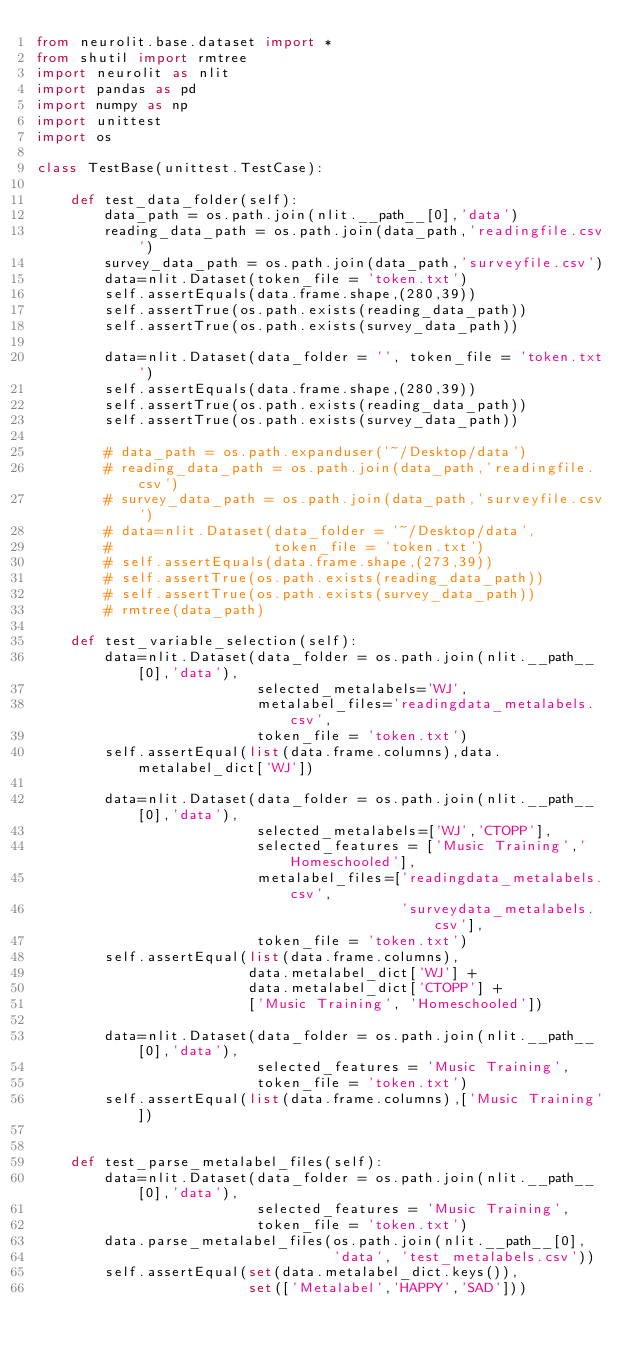<code> <loc_0><loc_0><loc_500><loc_500><_Python_>from neurolit.base.dataset import *
from shutil import rmtree
import neurolit as nlit
import pandas as pd
import numpy as np
import unittest
import os

class TestBase(unittest.TestCase):

    def test_data_folder(self):
        data_path = os.path.join(nlit.__path__[0],'data')
        reading_data_path = os.path.join(data_path,'readingfile.csv')
        survey_data_path = os.path.join(data_path,'surveyfile.csv')
        data=nlit.Dataset(token_file = 'token.txt')
        self.assertEquals(data.frame.shape,(280,39))
        self.assertTrue(os.path.exists(reading_data_path))
        self.assertTrue(os.path.exists(survey_data_path))

        data=nlit.Dataset(data_folder = '', token_file = 'token.txt')
        self.assertEquals(data.frame.shape,(280,39))
        self.assertTrue(os.path.exists(reading_data_path))
        self.assertTrue(os.path.exists(survey_data_path))

        # data_path = os.path.expanduser('~/Desktop/data')
        # reading_data_path = os.path.join(data_path,'readingfile.csv')
        # survey_data_path = os.path.join(data_path,'surveyfile.csv')
        # data=nlit.Dataset(data_folder = '~/Desktop/data',
        #                   token_file = 'token.txt')
        # self.assertEquals(data.frame.shape,(273,39))
        # self.assertTrue(os.path.exists(reading_data_path))
        # self.assertTrue(os.path.exists(survey_data_path))
        # rmtree(data_path)

    def test_variable_selection(self):
        data=nlit.Dataset(data_folder = os.path.join(nlit.__path__[0],'data'),
                          selected_metalabels='WJ',
                          metalabel_files='readingdata_metalabels.csv',
                          token_file = 'token.txt')
        self.assertEqual(list(data.frame.columns),data.metalabel_dict['WJ'])

        data=nlit.Dataset(data_folder = os.path.join(nlit.__path__[0],'data'),
                          selected_metalabels=['WJ','CTOPP'],
                          selected_features = ['Music Training','Homeschooled'],
                          metalabel_files=['readingdata_metalabels.csv',
                                           'surveydata_metalabels.csv'],
                          token_file = 'token.txt')
        self.assertEqual(list(data.frame.columns),
                         data.metalabel_dict['WJ'] +
                         data.metalabel_dict['CTOPP'] +
                         ['Music Training', 'Homeschooled'])

        data=nlit.Dataset(data_folder = os.path.join(nlit.__path__[0],'data'),
                          selected_features = 'Music Training',
                          token_file = 'token.txt')
        self.assertEqual(list(data.frame.columns),['Music Training'])


    def test_parse_metalabel_files(self):
        data=nlit.Dataset(data_folder = os.path.join(nlit.__path__[0],'data'),
                          selected_features = 'Music Training',
                          token_file = 'token.txt')
        data.parse_metalabel_files(os.path.join(nlit.__path__[0],
                                   'data', 'test_metalabels.csv'))
        self.assertEqual(set(data.metalabel_dict.keys()),
                         set(['Metalabel','HAPPY','SAD']))
</code> 